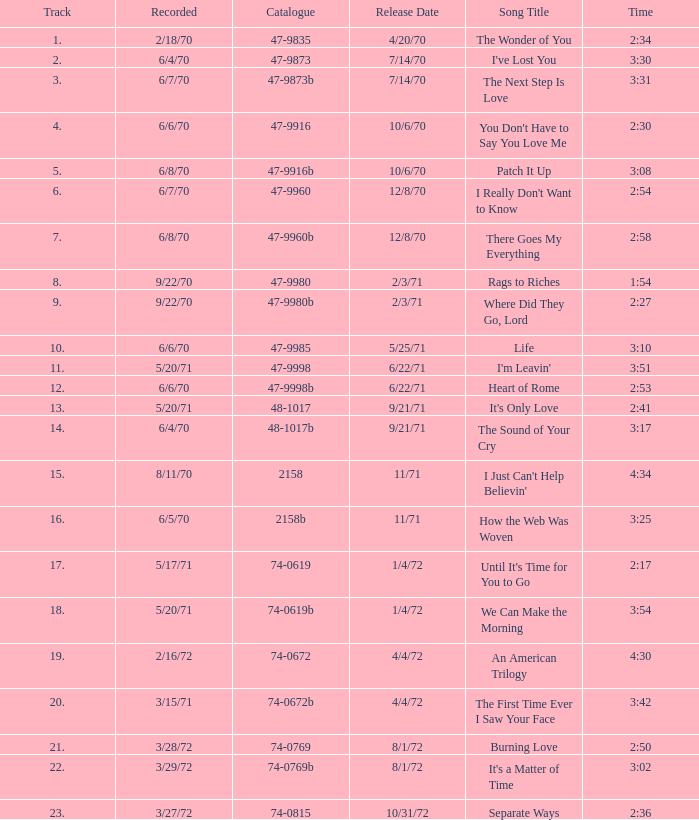What is the inventory number for the melody that is 3:17 and was unveiled on 9/21/71? 48-1017b. 